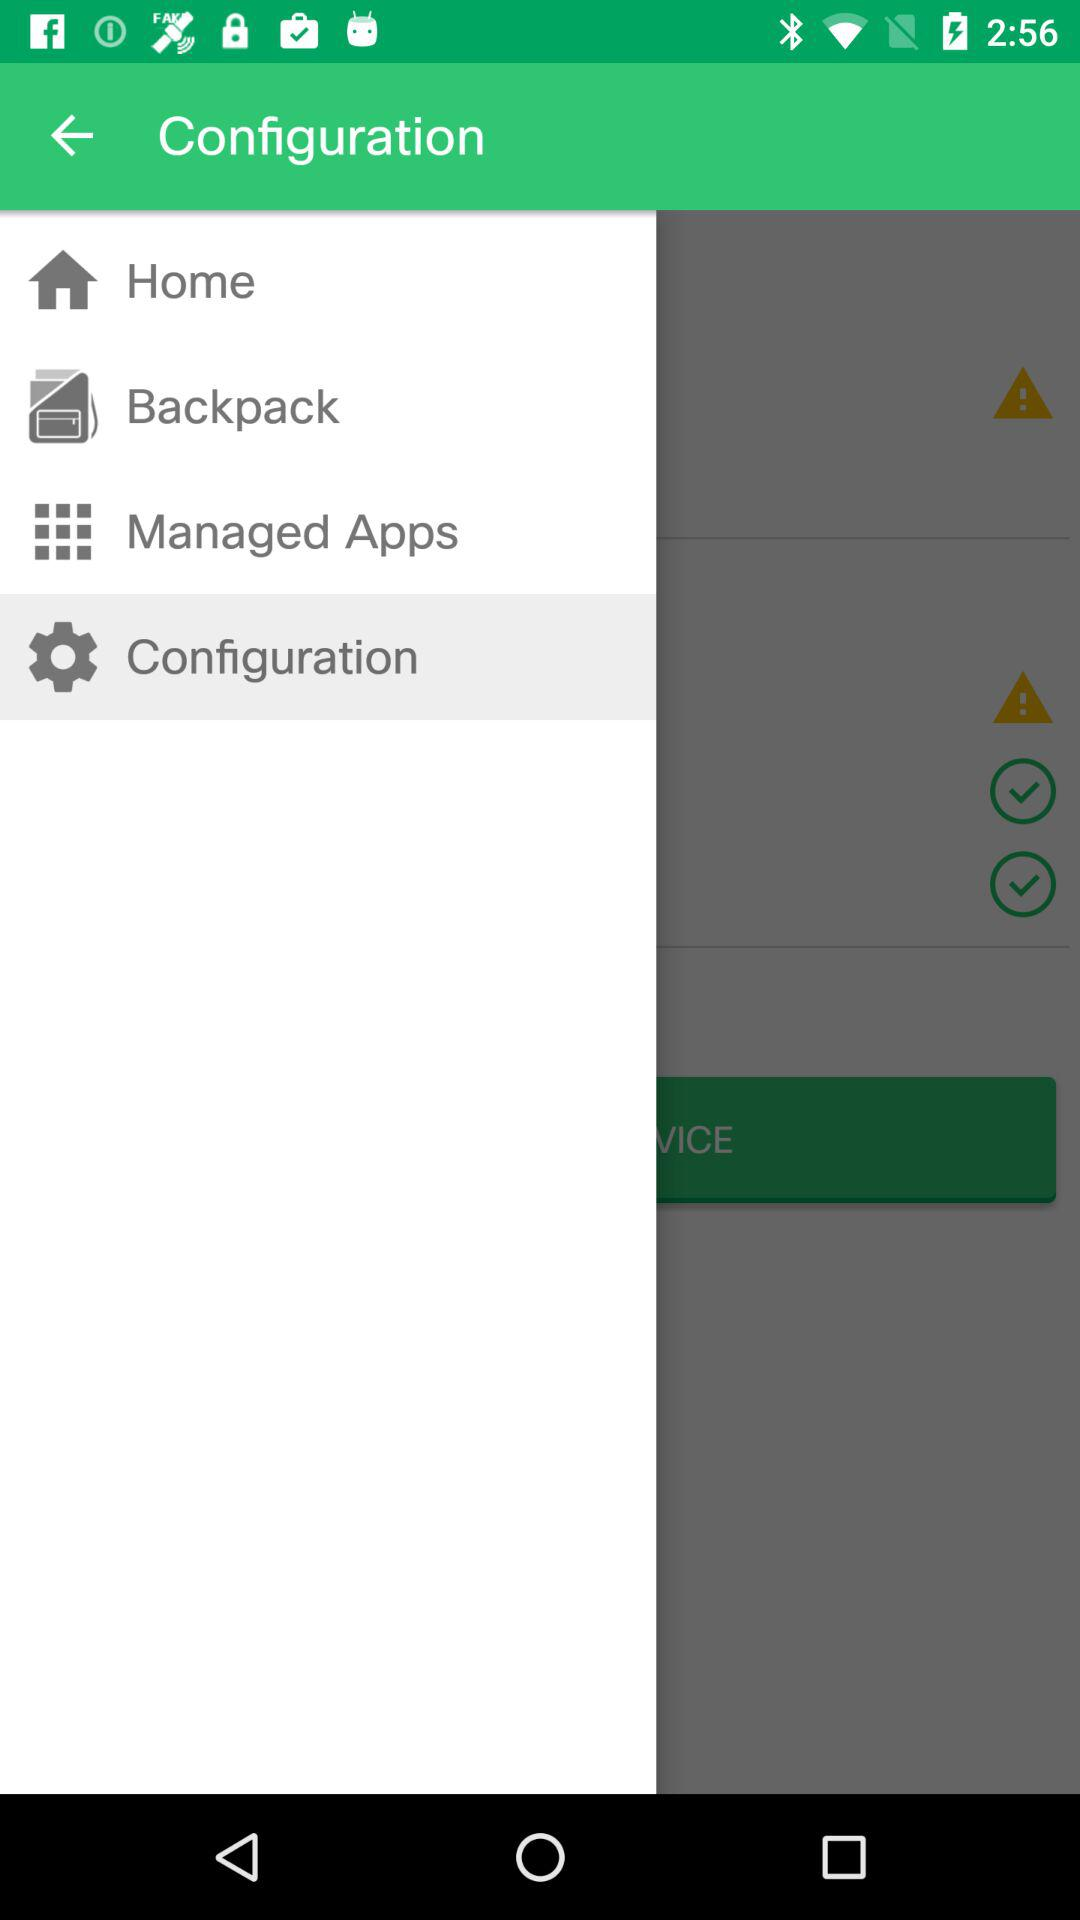Which item has been selected? The item that has been selected is "Configuration". 